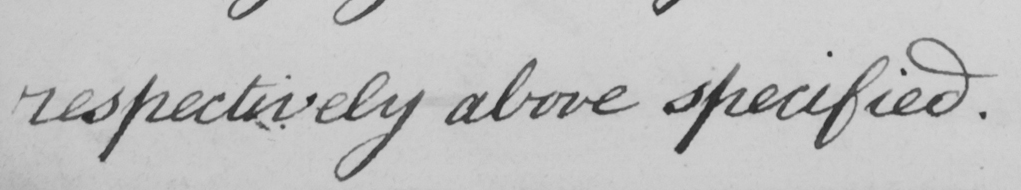Please provide the text content of this handwritten line. respectively above specified 